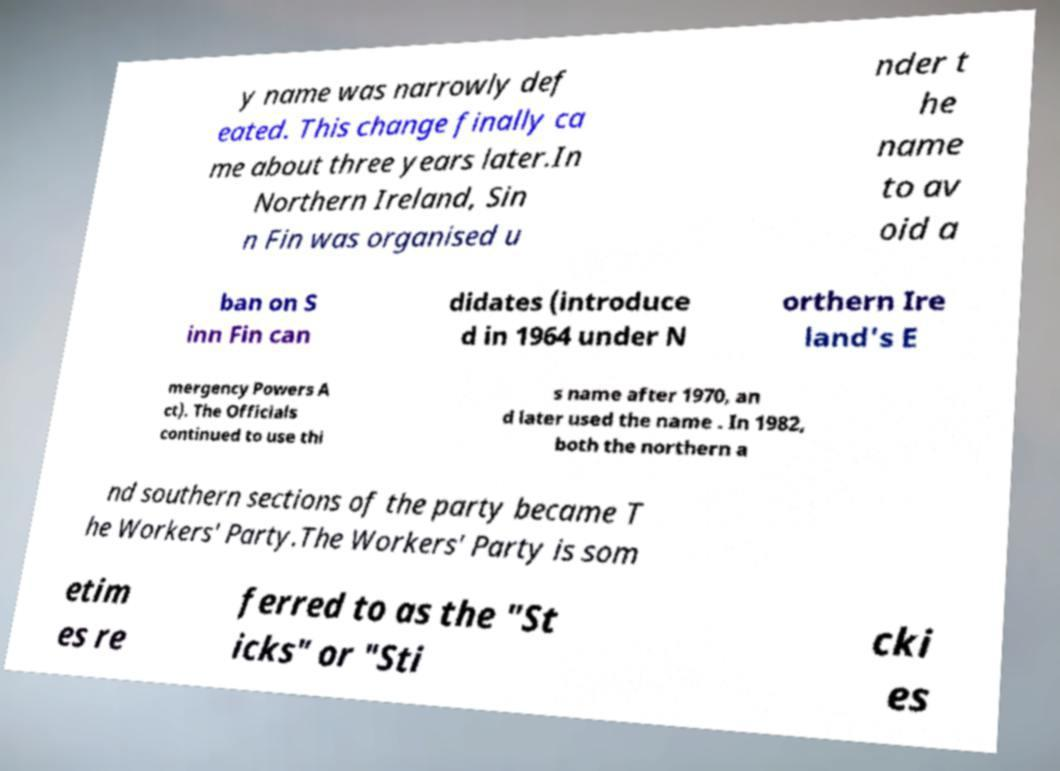Please identify and transcribe the text found in this image. y name was narrowly def eated. This change finally ca me about three years later.In Northern Ireland, Sin n Fin was organised u nder t he name to av oid a ban on S inn Fin can didates (introduce d in 1964 under N orthern Ire land's E mergency Powers A ct). The Officials continued to use thi s name after 1970, an d later used the name . In 1982, both the northern a nd southern sections of the party became T he Workers' Party.The Workers' Party is som etim es re ferred to as the "St icks" or "Sti cki es 